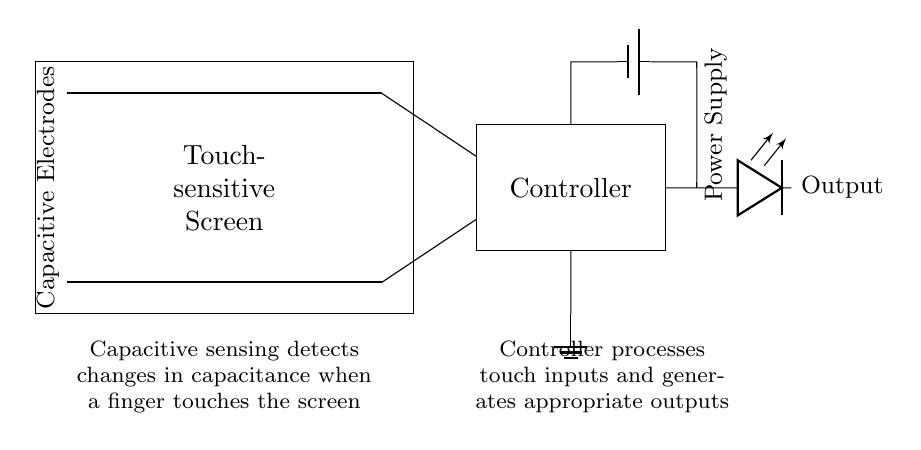What are the main components of this circuit? The main components of the circuit are the touch-sensitive screen, capacitive electrodes, controller, power supply, and output LED. Each of these parts is clearly labeled, providing a straightforward identification of the circuit elements.
Answer: Touch-sensitive screen, capacitive electrodes, controller, power supply, LED What type of sensing does this circuit utilize? The circuit uses capacitive sensing, as indicated by the label for capacitive electrodes. Capacitive sensing detects changes in capacitance, such as those caused by a finger touch, to register user inputs.
Answer: Capacitive sensing What does the controller do in this circuit? The controller processes touch inputs detected by the capacitive sensing and generates appropriate outputs, as described in the explanatory text. Its primary function is to interpret the signals from the touch-sensitive screen.
Answer: Processes touch inputs What is the role of the power supply? The power supply provides energy to the circuit to allow the operation of the components, including the controller and LED. This role is essential for the overall functionality of the touch-sensitive screen system.
Answer: Provides energy How do the outputs work in this circuit? The outputs work by lighting the LED whenever a touch input is detected and processed by the controller. The connection from the controller to the output indicates that actions based on user interaction are communicated visually.
Answer: By lighting the LED What is the purpose of the capacitive electrodes in this circuit? The purpose of the capacitive electrodes is to detect changes in capacitance when a finger approaches or touches the screen. This is crucial for intuitive user interaction since it enables the device to respond to touch.
Answer: To detect capacitance changes What is the orientation of the capacitive electrodes in the diagram? The capacitive electrodes are oriented horizontally across the screen as shown by the thick lines that span horizontally at the top and bottom of the rectangle representing the touch-sensitive screen.
Answer: Horizontal 